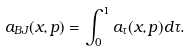<formula> <loc_0><loc_0><loc_500><loc_500>a _ { B J } ( x , p ) = \int _ { 0 } ^ { 1 } a _ { \tau } ( x , p ) d \tau .</formula> 